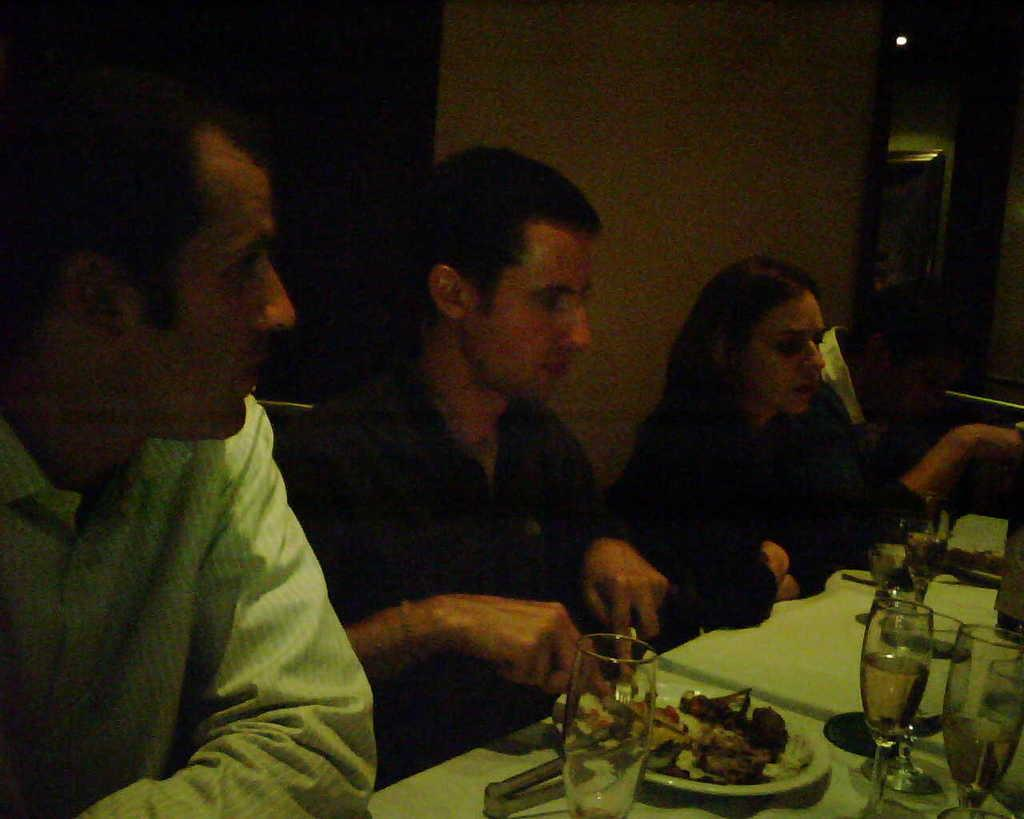How many people are in the image? There are four people in the image: three men and one woman. What are they doing in the image? They are sitting in front of a dining table. What items can be seen on the table? Wine glasses, plates, food, and forks are present on the table. What is behind the people in the image? There is a wall behind them. What type of heart-shaped object can be seen on the table? There is no heart-shaped object present on the table in the image. Is there a man standing behind the woman in the image? The facts do not mention a man standing behind the woman; there are only three men sitting in front of the table. 